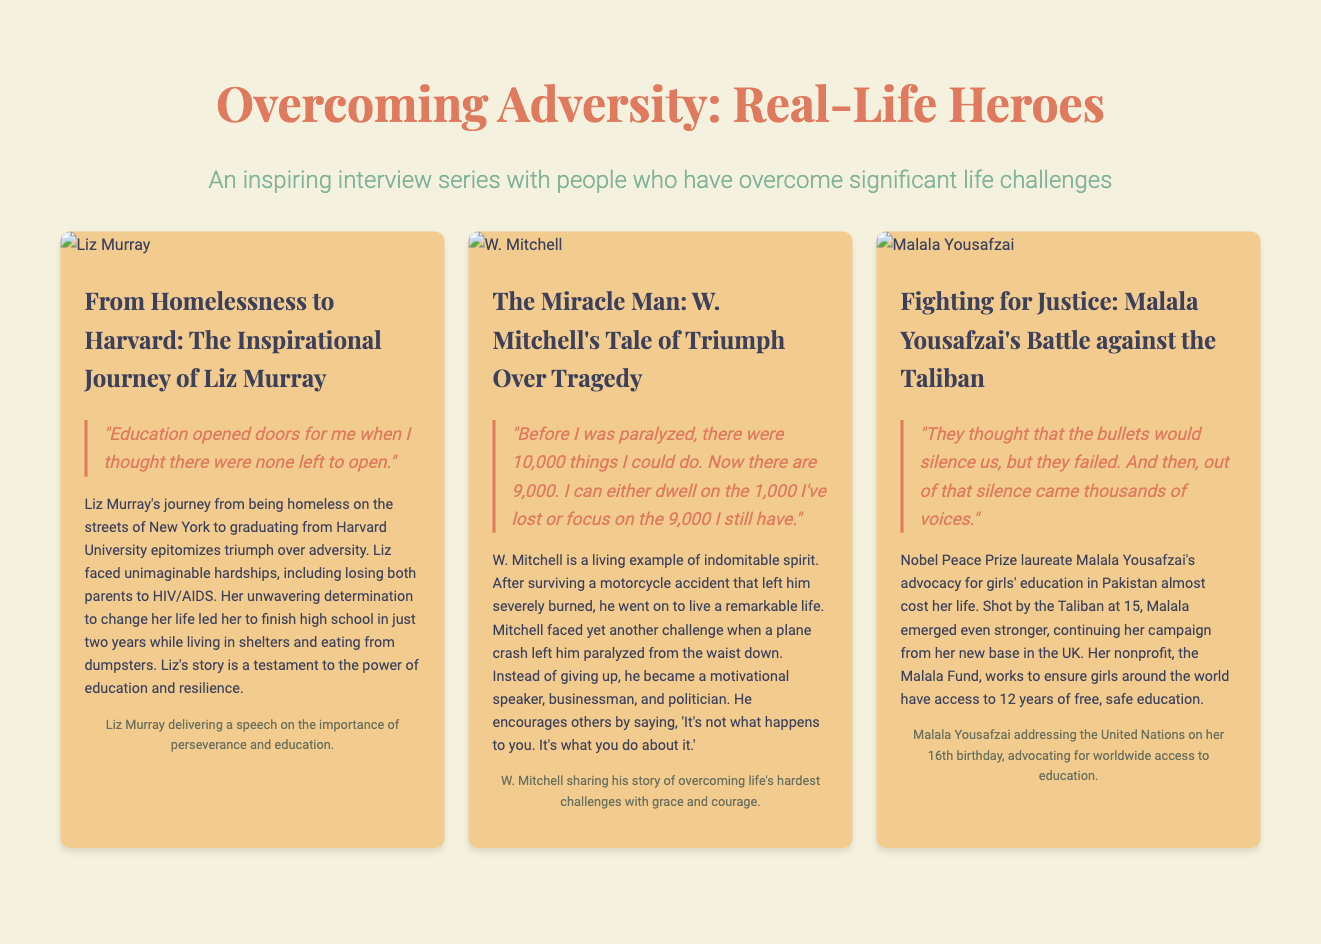What is the title of the series? The title of the series is presented prominently at the top of the document.
Answer: Overcoming Adversity: Real-Life Heroes Who is featured in the first interview? The first interview focuses on Liz Murray, as indicated by her name in the article section.
Answer: Liz Murray What university did Liz Murray graduate from? The document states that Liz Murray graduated from Harvard University.
Answer: Harvard University What is the central theme of Malala Yousafzai's advocacy? The document describes Malala Yousafzai's focus on education, particularly for girls.
Answer: Girls' education How many years of education does the Malala Fund aim to provide? The document explicitly mentions that the Malala Fund works to ensure access to 12 years of education.
Answer: 12 years Which inspirational quote is associated with W. Mitchell? The document features a quote that encapsulates W. Mitchell's viewpoint on challenges.
Answer: "It's not what happens to you. It's what you do about it." What major event occurred to Malala at age 15? The document outlines a significant event in Malala's life, which was an attack on her by the Taliban.
Answer: Shot by the Taliban What type of content is primarily presented in this document? The document compiles interview stories of individuals overcoming adversity, highlighting real-life heroes.
Answer: Interview series What significant achievement did W. Mitchell pursue after his accidents? The document highlights W. Mitchell's achievements in multiple fields after his life challenges.
Answer: Motivational speaker, businessman, and politician 